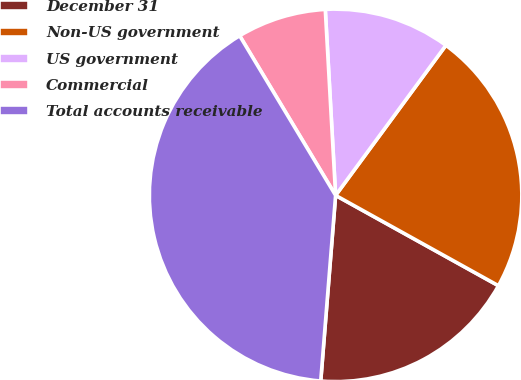Convert chart. <chart><loc_0><loc_0><loc_500><loc_500><pie_chart><fcel>December 31<fcel>Non-US government<fcel>US government<fcel>Commercial<fcel>Total accounts receivable<nl><fcel>18.21%<fcel>22.97%<fcel>10.97%<fcel>7.73%<fcel>40.11%<nl></chart> 